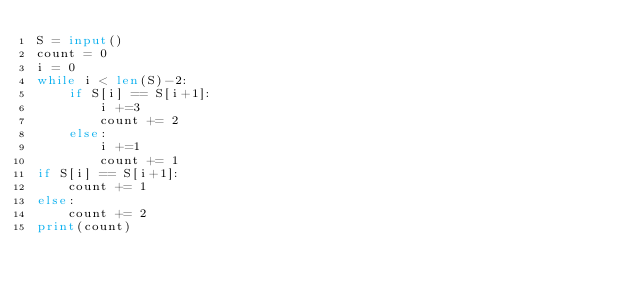<code> <loc_0><loc_0><loc_500><loc_500><_Python_>S = input()
count = 0
i = 0
while i < len(S)-2:
    if S[i] == S[i+1]:
        i +=3
        count += 2  
    else:
        i +=1
        count += 1
if S[i] == S[i+1]:
    count += 1
else:
    count += 2
print(count)</code> 